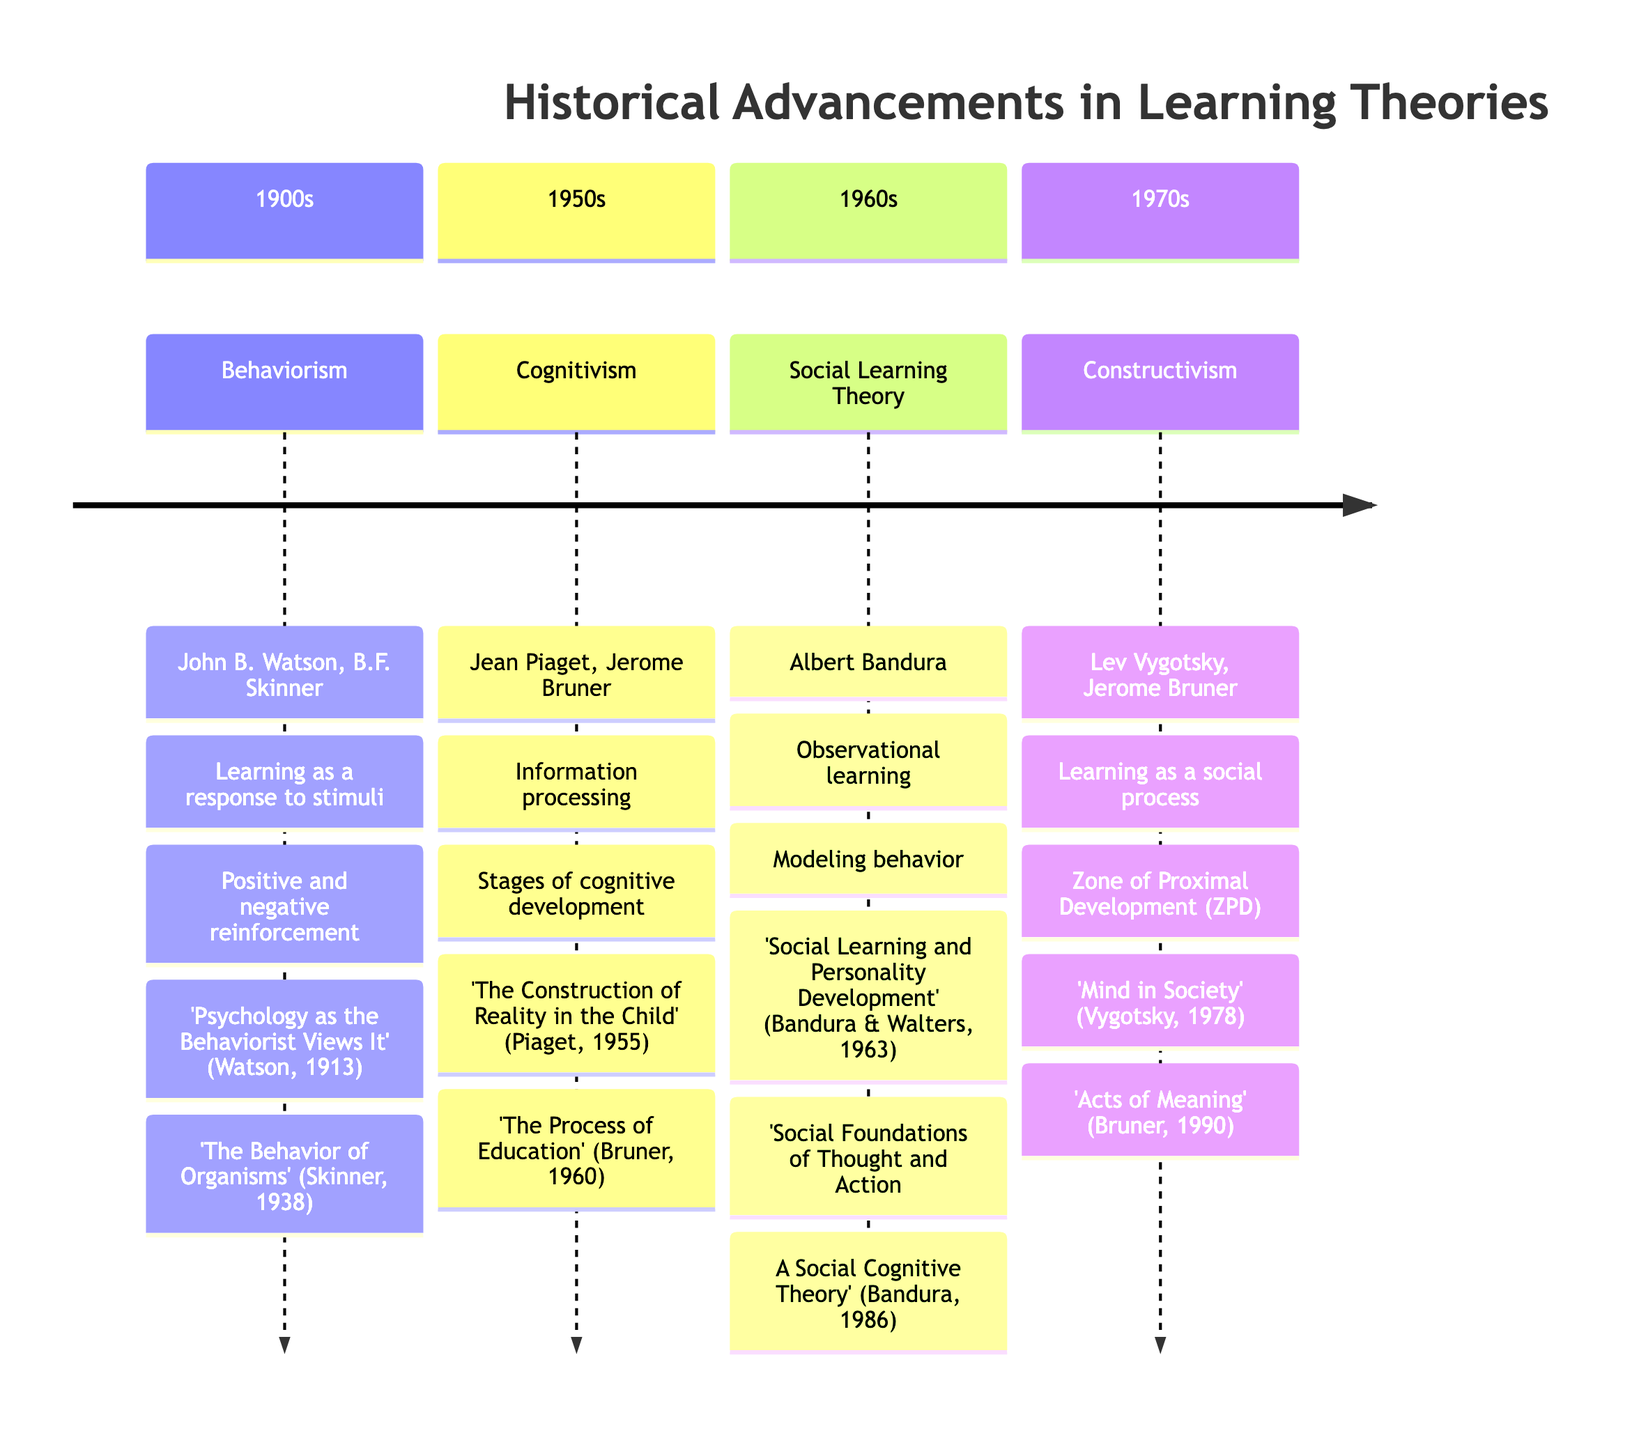What major theory is associated with John B. Watson? The timeline shows that John B. Watson is associated with Behaviorism, which is situated in the 1900s section of the diagram.
Answer: Behaviorism Who are the key figures in Cognitivism? The timeline lists Jean Piaget and Jerome Bruner as the key figures under the Cognitivism section from the 1950s.
Answer: Jean Piaget, Jerome Bruner What key concept is highlighted in the Social Learning Theory? The diagram indicates that "Observational learning" is a key concept of the Social Learning Theory from the 1960s.
Answer: Observational learning Which theory emphasizes the Zone of Proximal Development? In the timeline, Constructivism, marked in the 1970s, emphasizes the Zone of Proximal Development, as indicated in its key concepts.
Answer: Constructivism In which decade did the theory of Constructivism emerge? The timeline delineates that Constructivism emerged in the 1970s, as noted within its section.
Answer: 1970s What notable work was authored by B.F. Skinner? B.F. Skinner's notable work mentioned in the timeline is "The Behavior of Organisms," which is from the Behaviorism section.
Answer: "The Behavior of Organisms" How many major learning theories are represented on the timeline? By counting the sections in the timeline, there are four distinct theories presented, thus giving the total number of major learning theories.
Answer: 4 Which learning theory is associated with the concept of learning as a social process? The timeline specifies that Constructivism, which appears in the 1970s, is associated with the concept of learning as a social process.
Answer: Constructivism What work of Jerome Bruner is noted in the timeline? According to the timeline, "The Process of Education," authored by Jerome Bruner, is a notable work under the Cognitivism section from the 1950s.
Answer: "The Process of Education" 